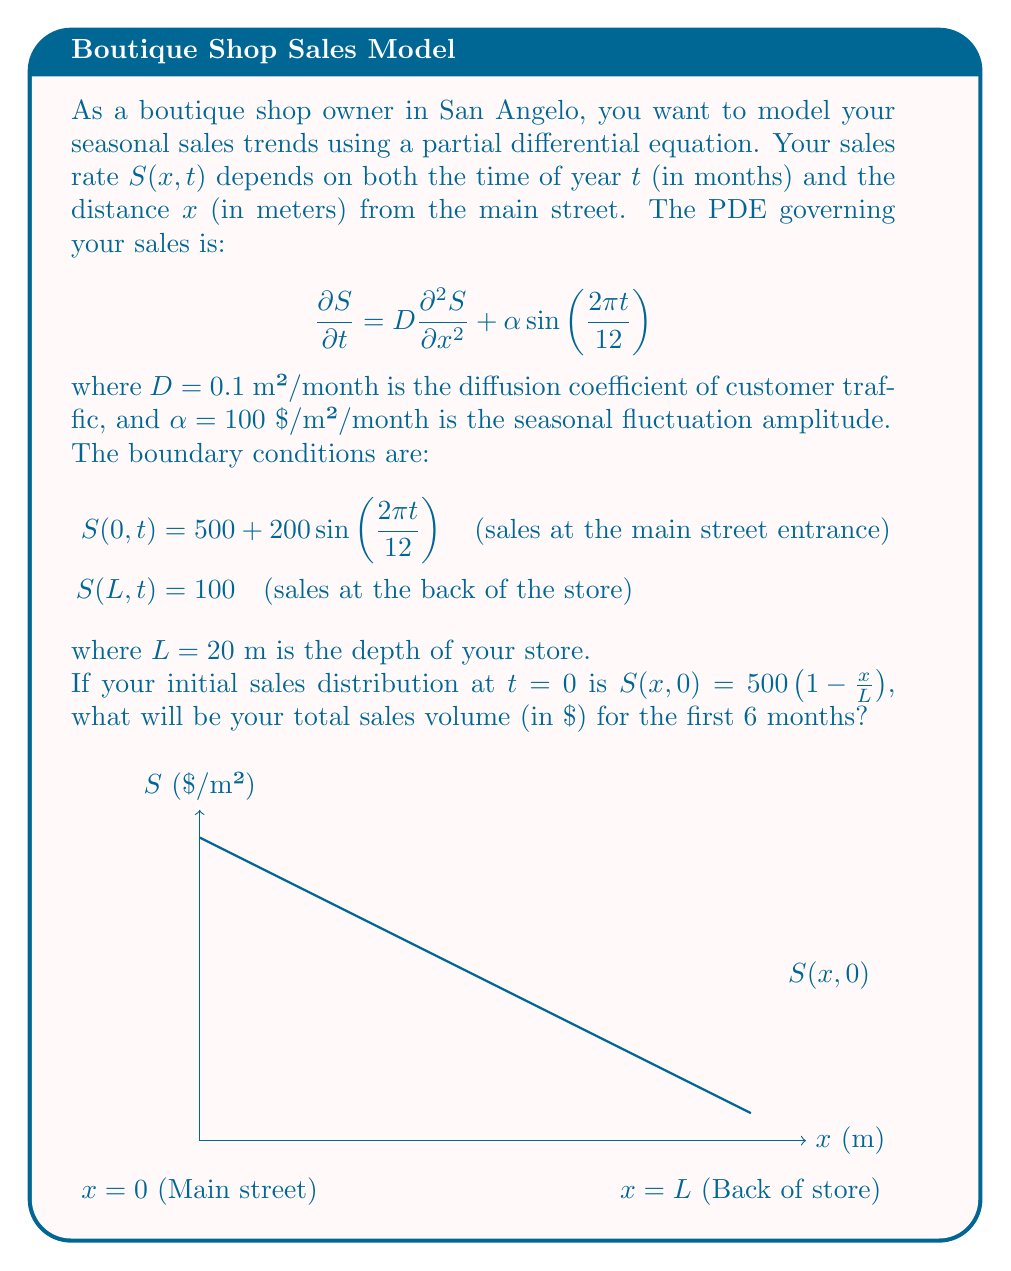Provide a solution to this math problem. To solve this problem, we need to follow these steps:

1) First, we need to solve the PDE numerically using a finite difference method or a spectral method, given the initial and boundary conditions. This is a complex process that typically requires computational tools.

2) Once we have the solution $S(x,t)$ for $0 \leq x \leq L$ and $0 \leq t \leq 6$, we need to integrate it over space and time to get the total sales volume.

3) The total sales volume $V$ is given by:

   $$V = \int_0^6 \int_0^L S(x,t) dx dt$$

4) Since we don't have an explicit analytical solution for $S(x,t)$, we would need to use numerical integration techniques to evaluate this double integral.

5) The result of this integration would give us the total sales volume in $/m² · month. To convert this to total dollars, we need to multiply by the width of the store (which isn't given in the problem, so let's assume it's 1 meter for simplicity).

6) The exact value would depend on the numerical methods used to solve the PDE and evaluate the integral. However, we can make some observations about the expected result:

   - The initial sales distribution decreases linearly from 500 $/m² at the entrance to 100 $/m² at the back.
   - The sales at the entrance fluctuate between 300 $/m² and 700 $/m² over the year.
   - The seasonal term in the PDE will cause overall sales to increase during the first 3 months and decrease during the next 3 months.

7) Given these factors, we might expect the average sales rate to be around 400 $/m²/month. Over 6 months and 20 meters of store depth, this would result in a total sales volume of approximately:

   $$V \approx 400 \text{ }/m²/\text{month} \cdot 6 \text{ months} \cdot 20 \text{ m} = 48,000 \text{ }$$

This is a rough estimate. The actual result from a numerical solution would be more accurate.
Answer: Approximately $48,000 (exact value depends on numerical methods used) 